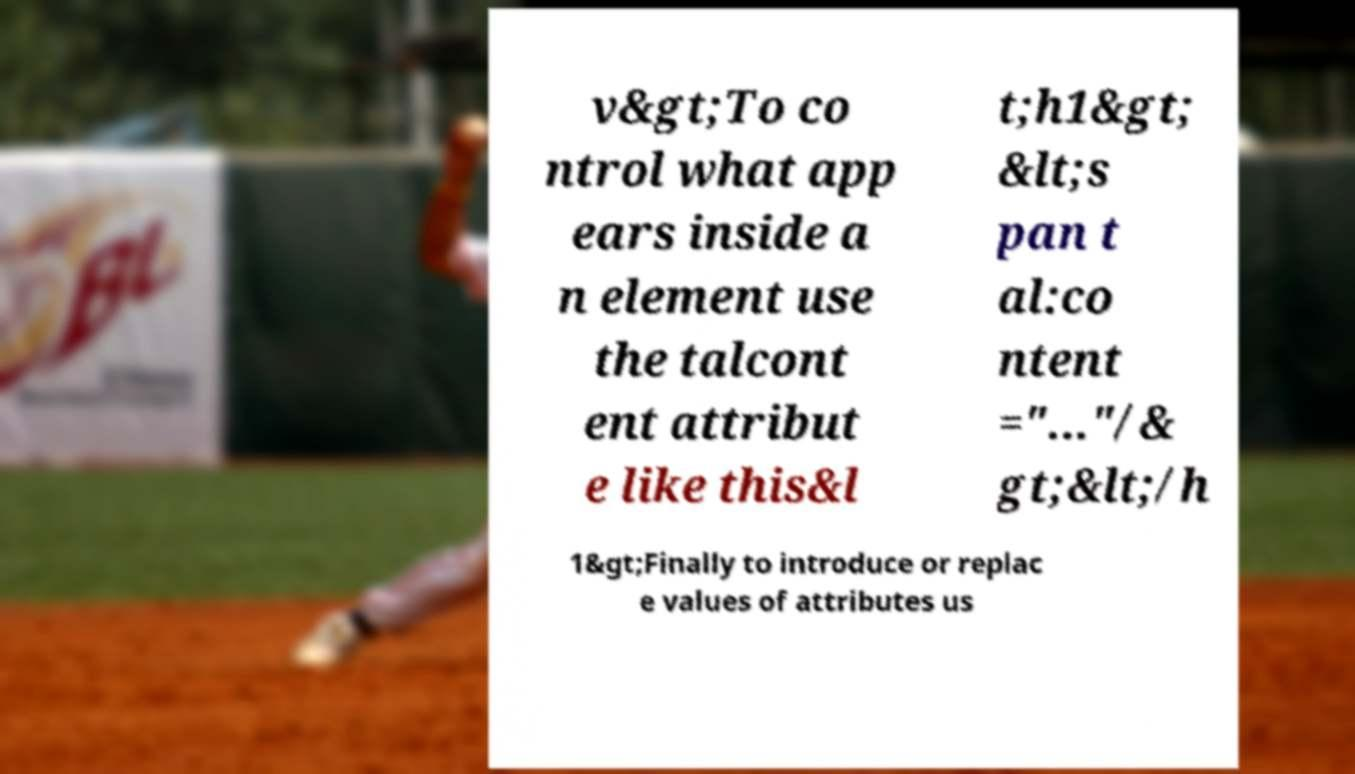There's text embedded in this image that I need extracted. Can you transcribe it verbatim? v&gt;To co ntrol what app ears inside a n element use the talcont ent attribut e like this&l t;h1&gt; &lt;s pan t al:co ntent ="..."/& gt;&lt;/h 1&gt;Finally to introduce or replac e values of attributes us 